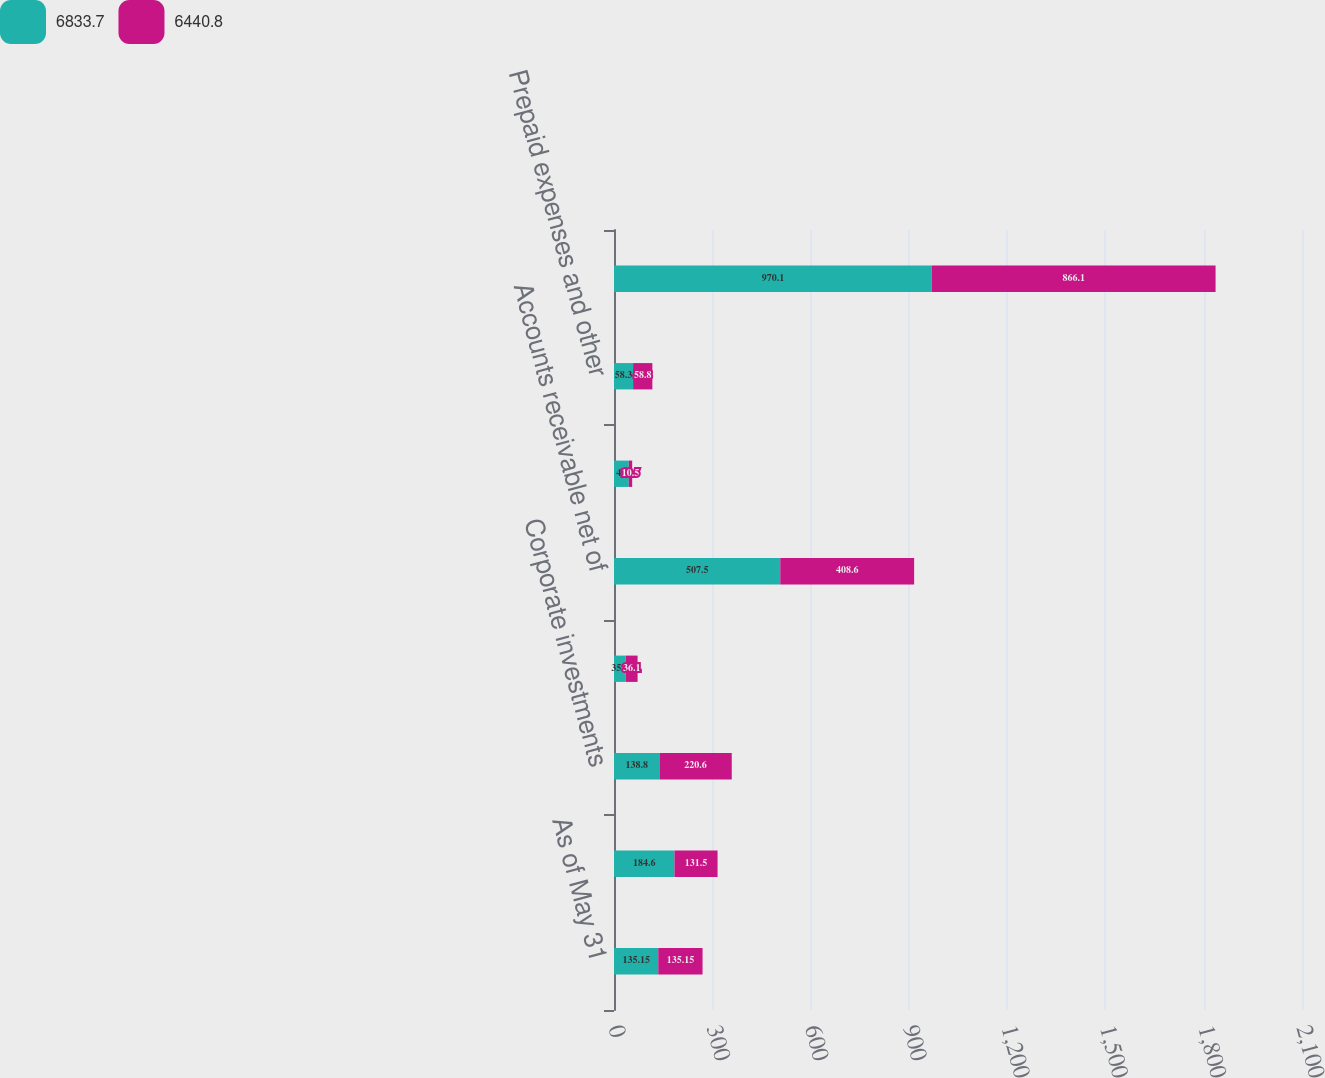Convert chart. <chart><loc_0><loc_0><loc_500><loc_500><stacked_bar_chart><ecel><fcel>As of May 31<fcel>Cash and cash equivalents<fcel>Corporate investments<fcel>Interest receivable<fcel>Accounts receivable net of<fcel>Prepaid income taxes<fcel>Prepaid expenses and other<fcel>Current assets before funds<nl><fcel>6833.7<fcel>135.15<fcel>184.6<fcel>138.8<fcel>35.9<fcel>507.5<fcel>45<fcel>58.3<fcel>970.1<nl><fcel>6440.8<fcel>135.15<fcel>131.5<fcel>220.6<fcel>36.1<fcel>408.6<fcel>10.5<fcel>58.8<fcel>866.1<nl></chart> 